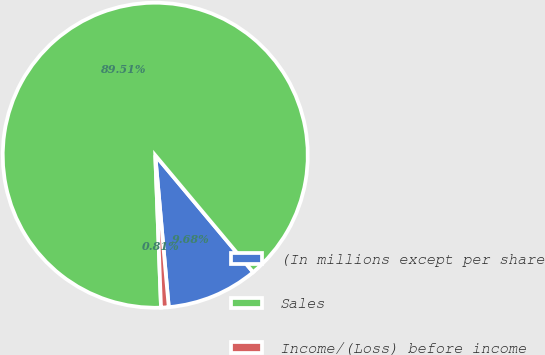Convert chart to OTSL. <chart><loc_0><loc_0><loc_500><loc_500><pie_chart><fcel>(In millions except per share<fcel>Sales<fcel>Income/(Loss) before income<nl><fcel>9.68%<fcel>89.52%<fcel>0.81%<nl></chart> 